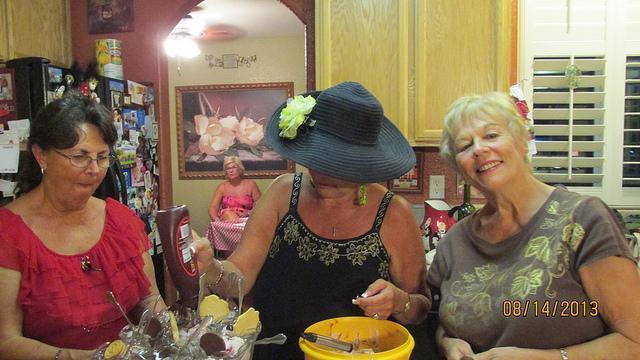How many people are wearing hats?
Give a very brief answer. 1. How many people are cooking?
Give a very brief answer. 3. How many people are in the photo?
Give a very brief answer. 4. 